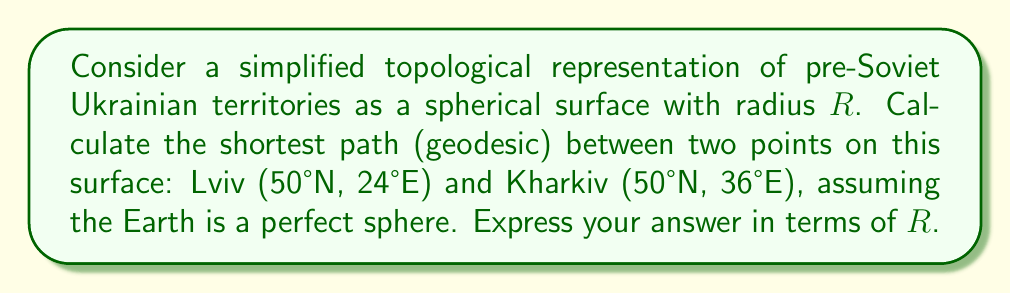Give your solution to this math problem. To solve this problem, we'll follow these steps:

1) On a sphere, geodesics are great circles. The shortest path between two points on a sphere is along the arc of the great circle passing through both points.

2) Given the coordinates, we can see that both cities are on the same latitude (50°N). However, they differ in longitude by 12° (36°E - 24°E = 12°).

3) The distance along a parallel of latitude is not a geodesic unless the latitude is the equator. We need to calculate the central angle $\theta$ between these points.

4) For points on the same latitude, we can use the formula:

   $$\cos\theta = \sin^2\lambda + \cos^2\lambda \cos\Delta\phi$$

   where $\lambda$ is the latitude and $\Delta\phi$ is the difference in longitude.

5) Substituting our values:
   
   $$\cos\theta = \sin^2(50°) + \cos^2(50°) \cos(12°)$$

6) Calculating:
   
   $$\cos\theta \approx 0.9829$$

7) Taking the arccos:
   
   $$\theta \approx 0.1855 \text{ radians}$$

8) The length of the geodesic is then:
   
   $$s = R\theta \approx 0.1855R$$

This represents the shortest path on our spherical model of pre-Soviet Ukrainian territories, unaffected by artificial Soviet-imposed boundaries.
Answer: $0.1855R$ 